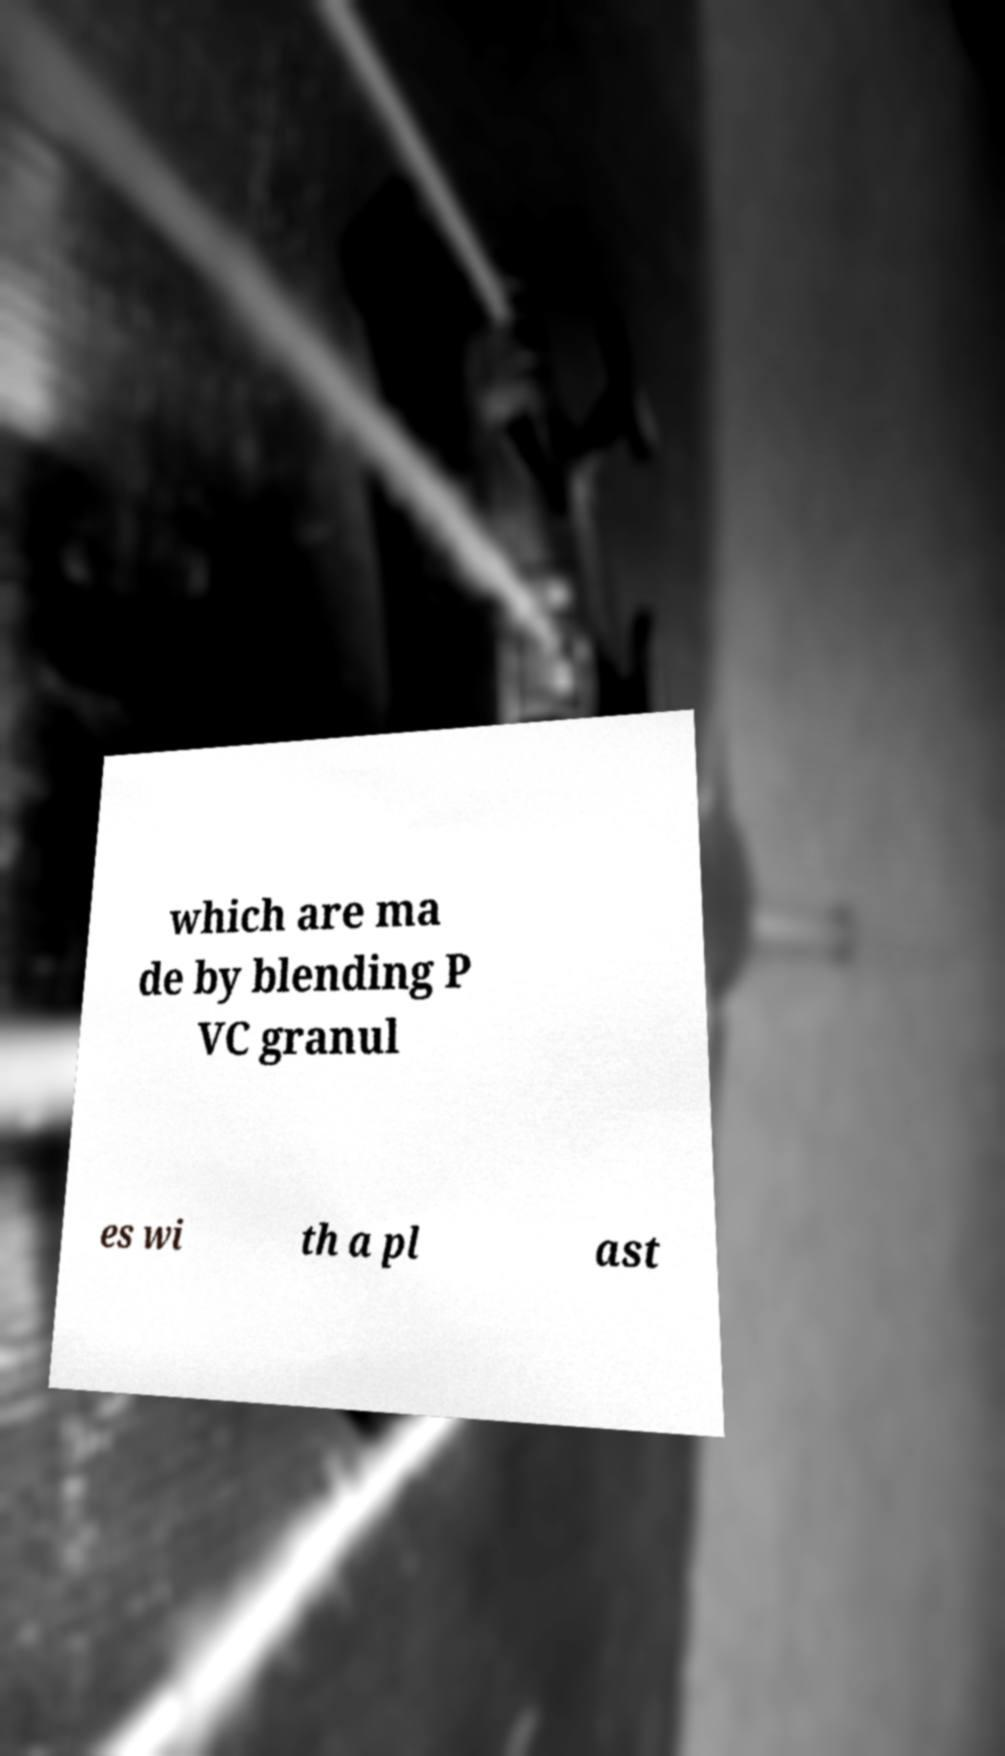Can you accurately transcribe the text from the provided image for me? which are ma de by blending P VC granul es wi th a pl ast 